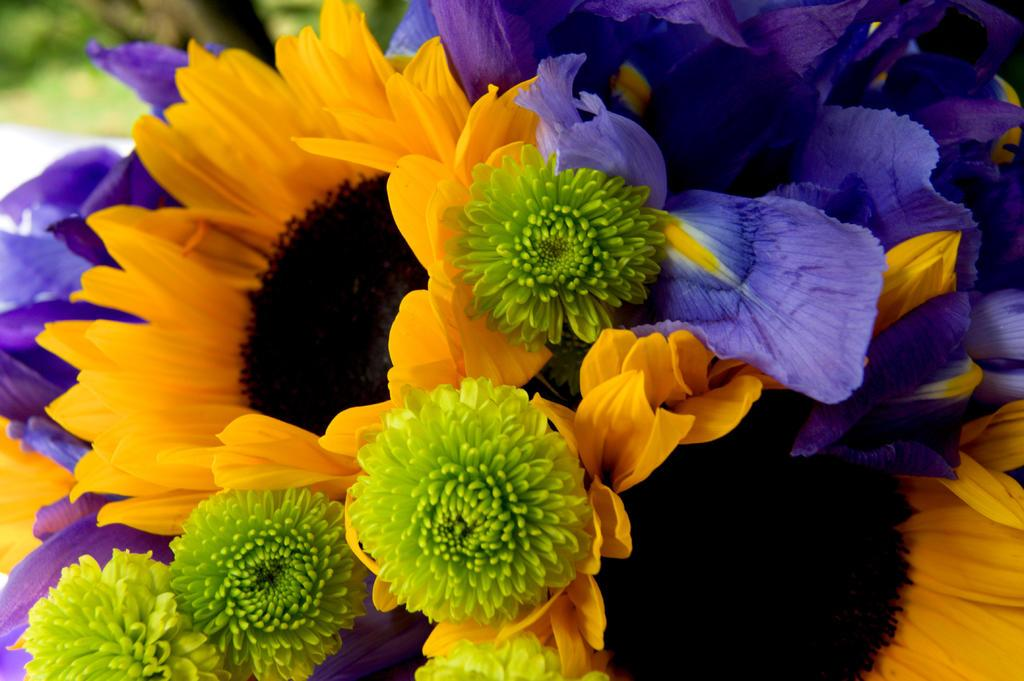What type of living organisms can be seen in the image? There are flowers in the image. What type of guide can be seen leading the family of hens in the image? There is no guide, family, or hens present in the image; it only features flowers. 